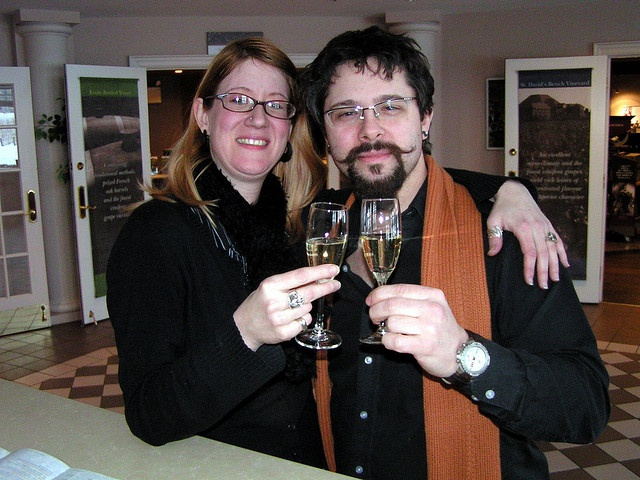Describe the objects in this image and their specific colors. I can see people in black, brown, and lightgray tones, people in black, darkgray, gray, and lightpink tones, wine glass in black, gray, maroon, and white tones, wine glass in black, gray, darkgray, and maroon tones, and clock in black, white, lightblue, and darkgray tones in this image. 